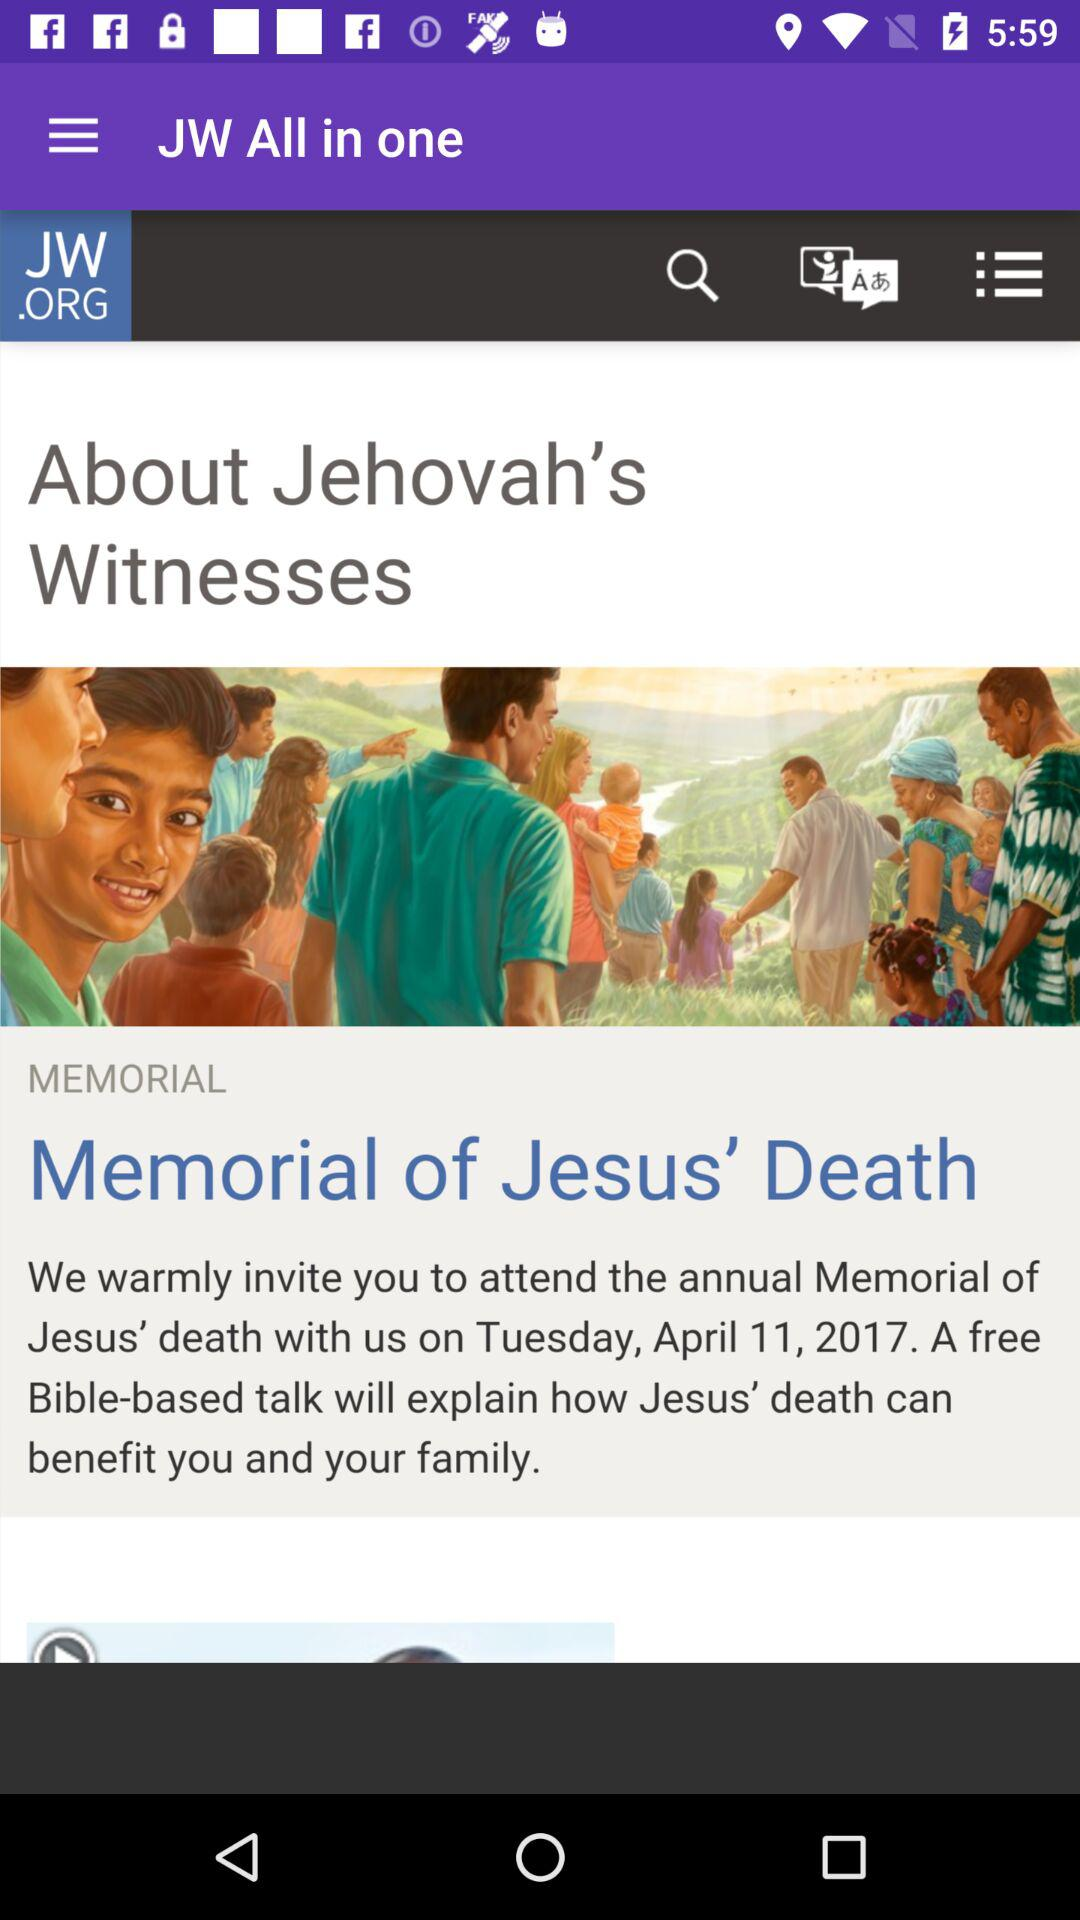What is the app name? The app name is "JW All in one". 